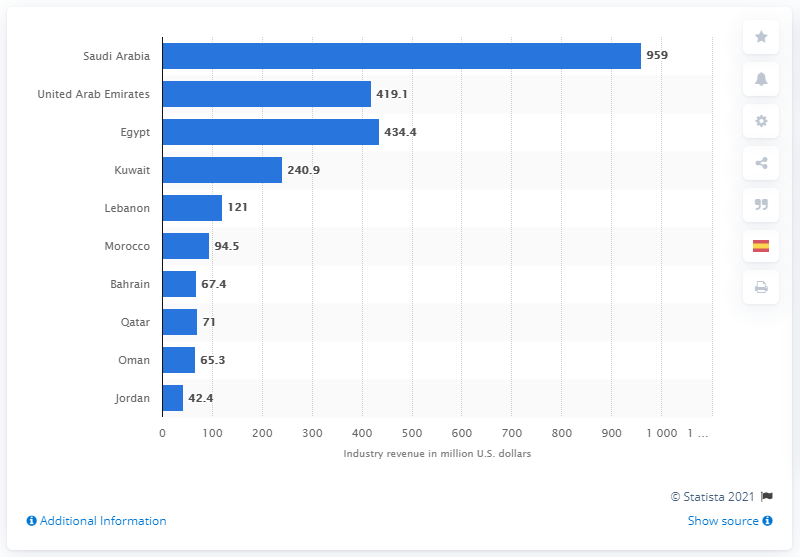Highlight a few significant elements in this photo. In 2019, the fitness and health club industry in Egypt generated a revenue of approximately 434.4 million U.S. dollars. 